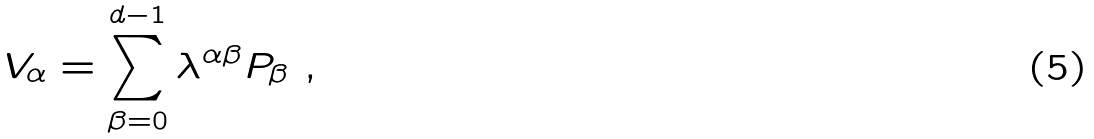Convert formula to latex. <formula><loc_0><loc_0><loc_500><loc_500>V _ { \alpha } = \sum _ { \beta = 0 } ^ { d - 1 } \lambda ^ { \alpha \beta } P _ { \beta } \ ,</formula> 